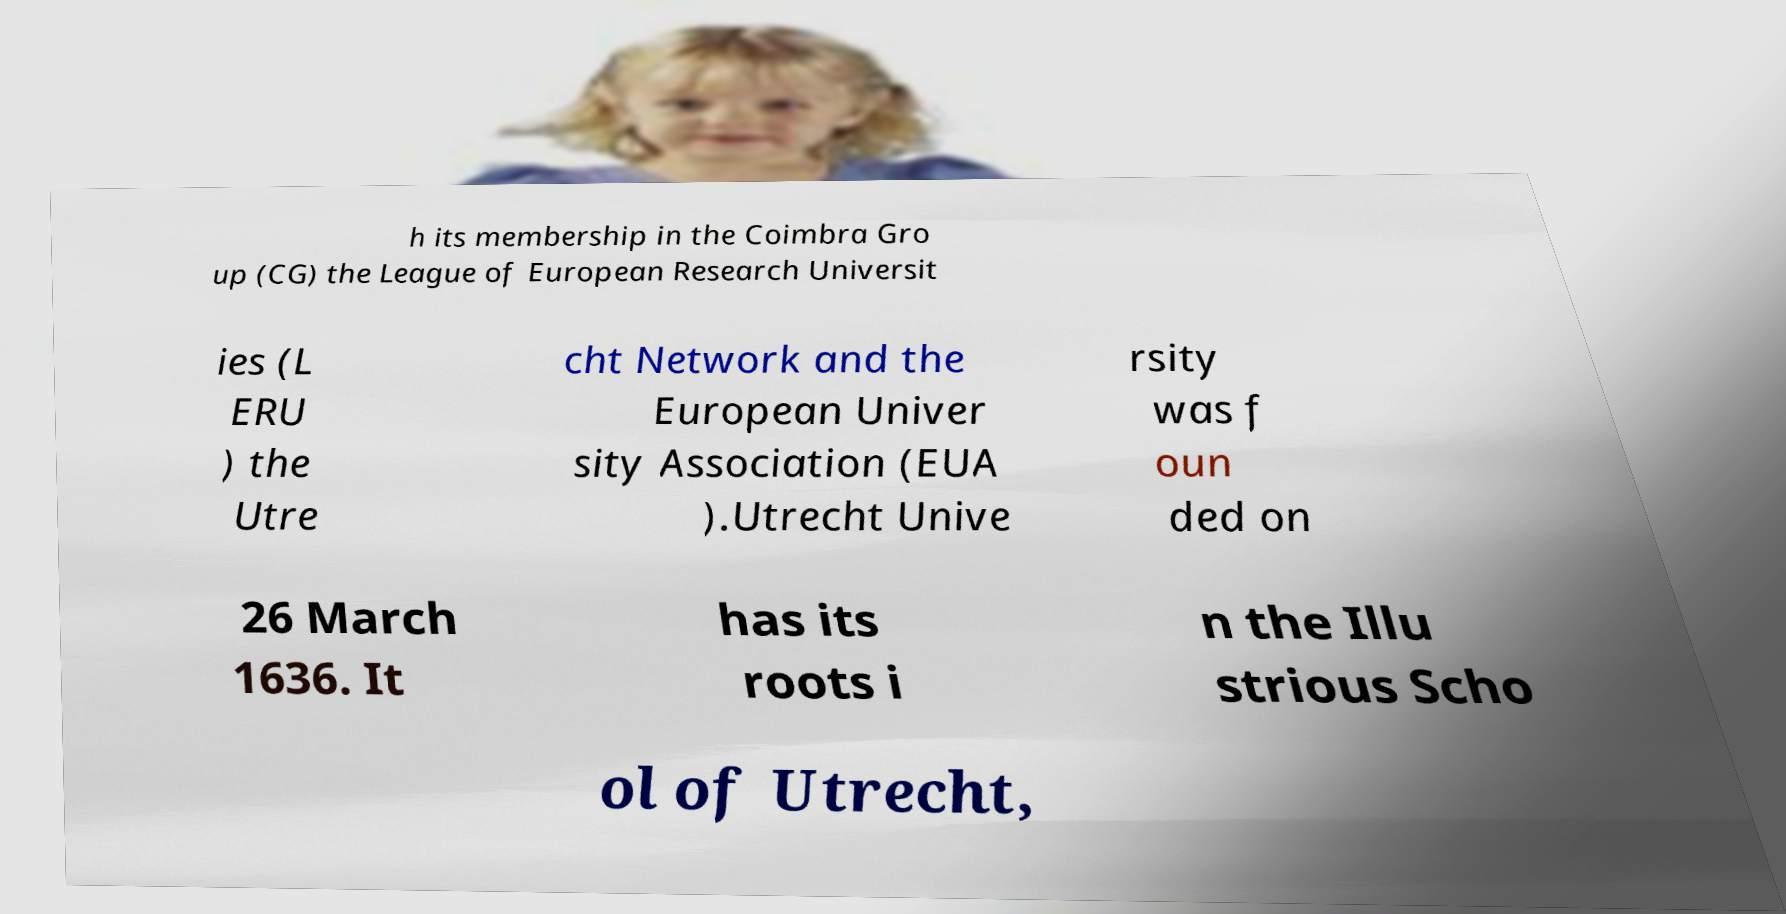What messages or text are displayed in this image? I need them in a readable, typed format. h its membership in the Coimbra Gro up (CG) the League of European Research Universit ies (L ERU ) the Utre cht Network and the European Univer sity Association (EUA ).Utrecht Unive rsity was f oun ded on 26 March 1636. It has its roots i n the Illu strious Scho ol of Utrecht, 